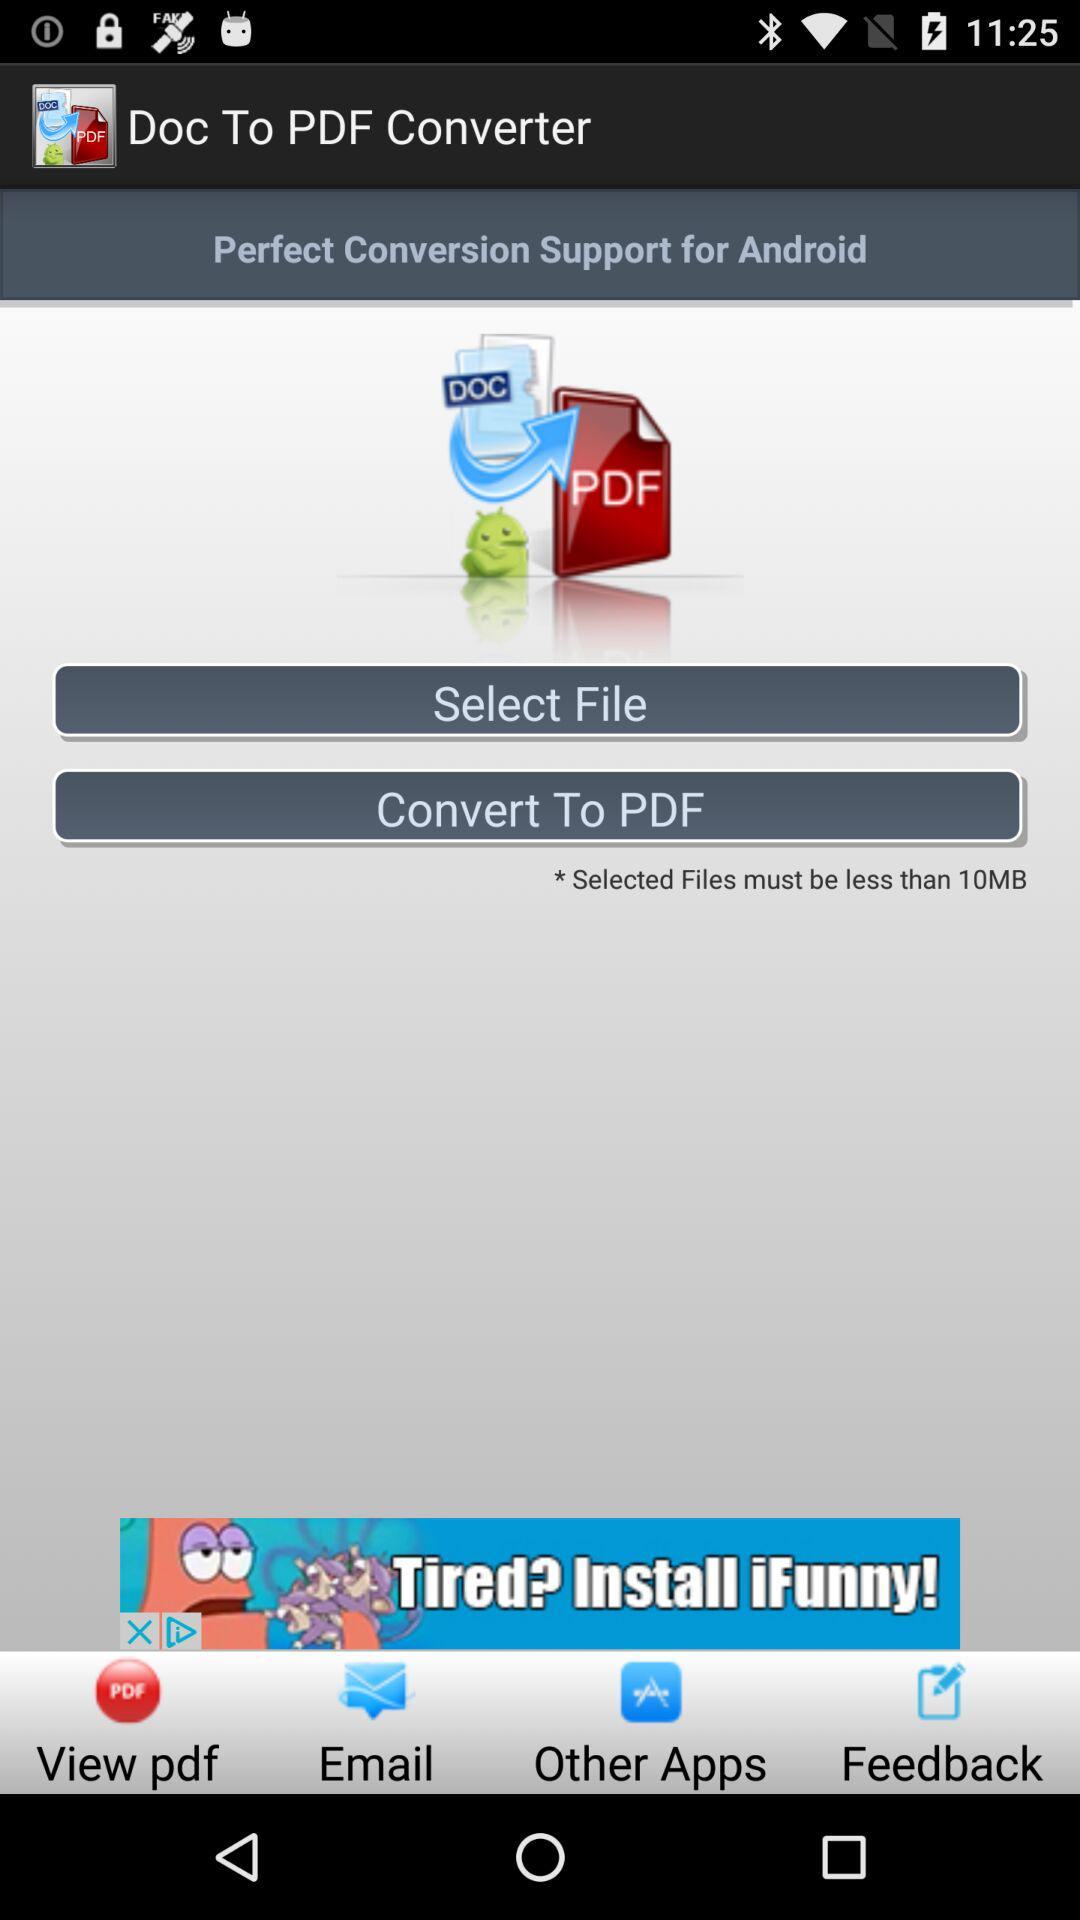How many MB is the file size limit?
Answer the question using a single word or phrase. 10 